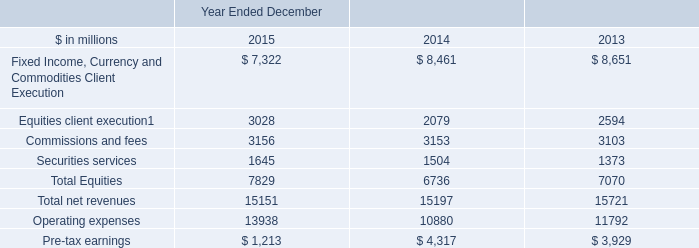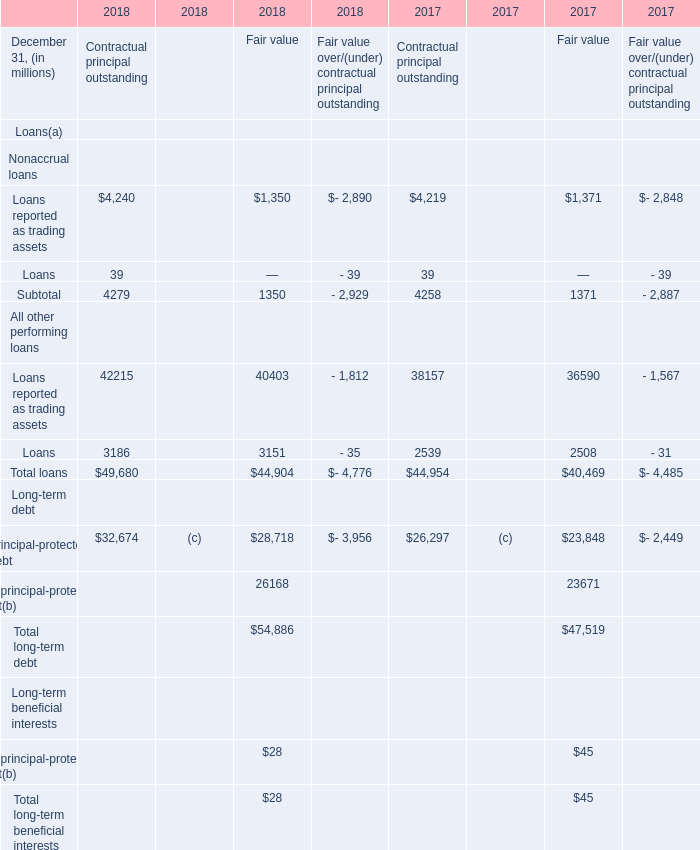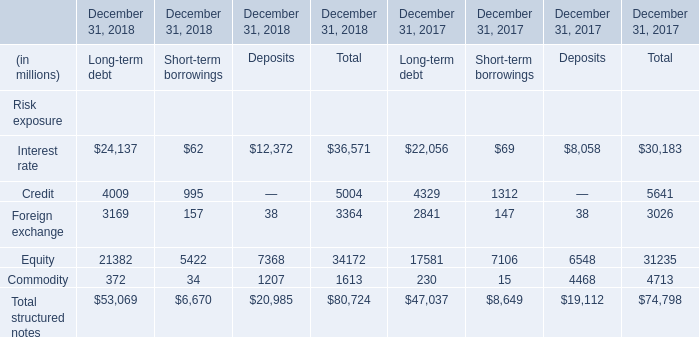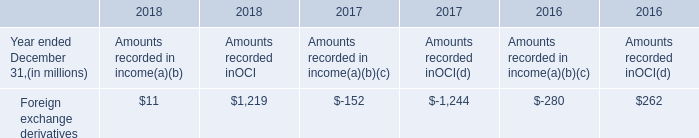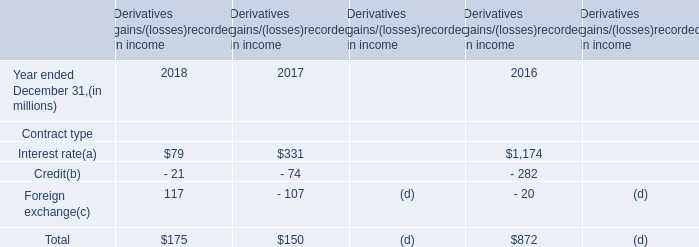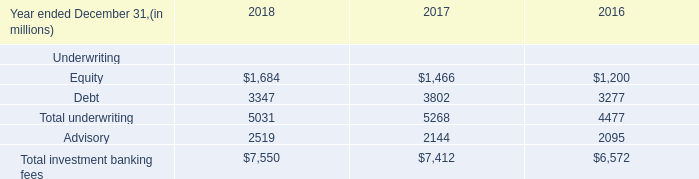What's the current increasing rate of Principal-protected debt for Fair value? 
Computations: ((28718 - 23848) / 23848)
Answer: 0.20421. 